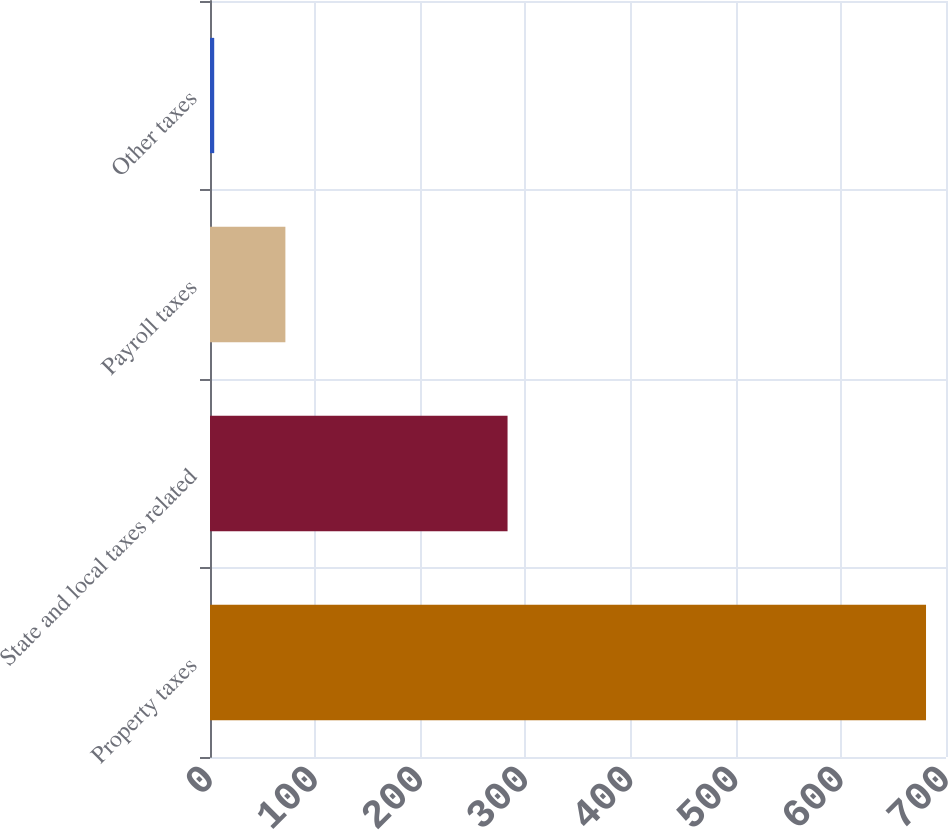Convert chart. <chart><loc_0><loc_0><loc_500><loc_500><bar_chart><fcel>Property taxes<fcel>State and local taxes related<fcel>Payroll taxes<fcel>Other taxes<nl><fcel>681<fcel>283<fcel>71.7<fcel>4<nl></chart> 